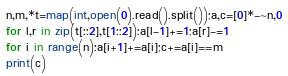Convert code to text. <code><loc_0><loc_0><loc_500><loc_500><_Python_>n,m,*t=map(int,open(0).read().split());a,c=[0]*-~n,0
for l,r in zip(t[::2],t[1::2]):a[l-1]+=1;a[r]-=1
for i in range(n):a[i+1]+=a[i];c+=a[i]==m
print(c)</code> 